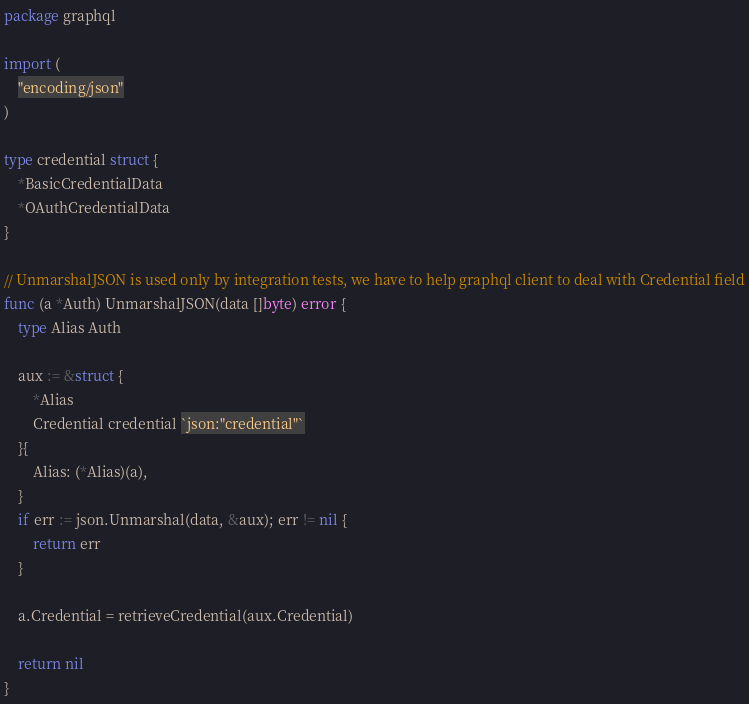Convert code to text. <code><loc_0><loc_0><loc_500><loc_500><_Go_>package graphql

import (
	"encoding/json"
)

type credential struct {
	*BasicCredentialData
	*OAuthCredentialData
}

// UnmarshalJSON is used only by integration tests, we have to help graphql client to deal with Credential field
func (a *Auth) UnmarshalJSON(data []byte) error {
	type Alias Auth

	aux := &struct {
		*Alias
		Credential credential `json:"credential"`
	}{
		Alias: (*Alias)(a),
	}
	if err := json.Unmarshal(data, &aux); err != nil {
		return err
	}

	a.Credential = retrieveCredential(aux.Credential)

	return nil
}
</code> 